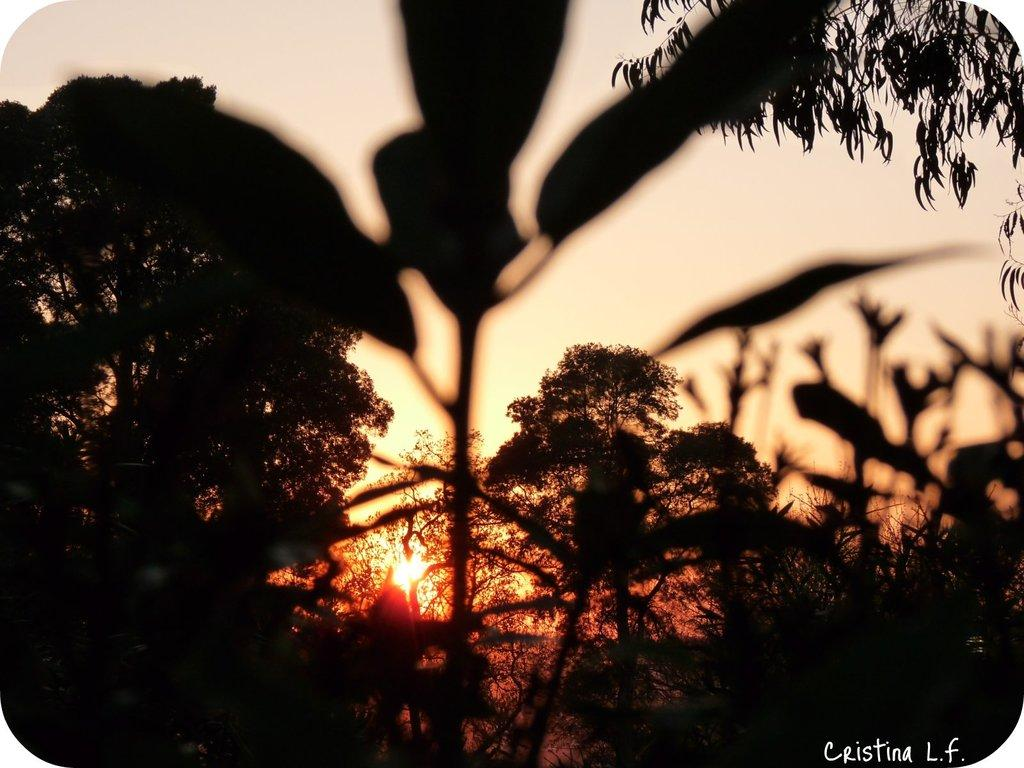What type of vegetation can be seen in the image? There are plants and trees in the image. Can you describe the background of the image? The sun is visible in the background of the image. What type of cheese can be seen hanging from the trees in the image? There is no cheese present in the image; it features plants, trees, and the sun in the background. 